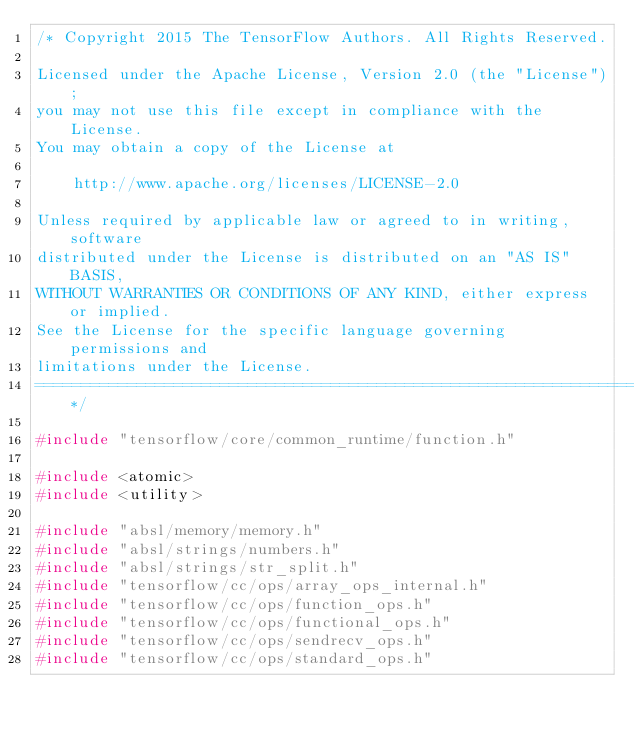<code> <loc_0><loc_0><loc_500><loc_500><_C++_>/* Copyright 2015 The TensorFlow Authors. All Rights Reserved.

Licensed under the Apache License, Version 2.0 (the "License");
you may not use this file except in compliance with the License.
You may obtain a copy of the License at

    http://www.apache.org/licenses/LICENSE-2.0

Unless required by applicable law or agreed to in writing, software
distributed under the License is distributed on an "AS IS" BASIS,
WITHOUT WARRANTIES OR CONDITIONS OF ANY KIND, either express or implied.
See the License for the specific language governing permissions and
limitations under the License.
==============================================================================*/

#include "tensorflow/core/common_runtime/function.h"

#include <atomic>
#include <utility>

#include "absl/memory/memory.h"
#include "absl/strings/numbers.h"
#include "absl/strings/str_split.h"
#include "tensorflow/cc/ops/array_ops_internal.h"
#include "tensorflow/cc/ops/function_ops.h"
#include "tensorflow/cc/ops/functional_ops.h"
#include "tensorflow/cc/ops/sendrecv_ops.h"
#include "tensorflow/cc/ops/standard_ops.h"</code> 